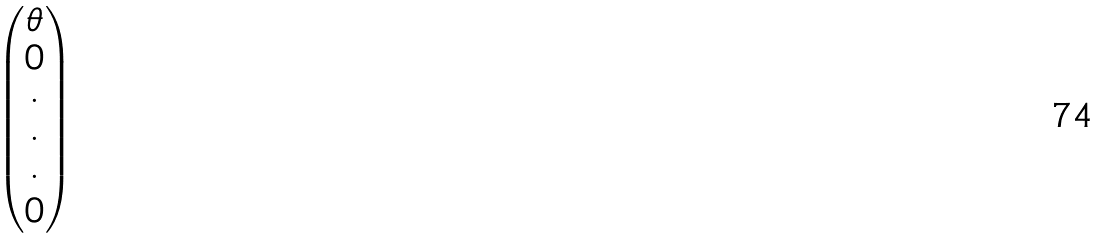Convert formula to latex. <formula><loc_0><loc_0><loc_500><loc_500>\begin{pmatrix} \theta \\ 0 \\ \cdot \\ \cdot \\ \cdot \\ 0 \end{pmatrix}</formula> 